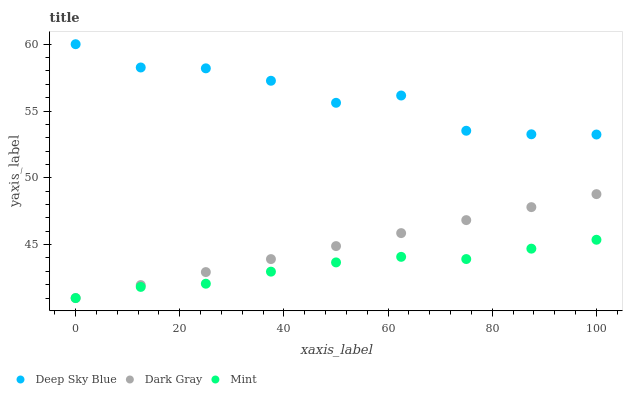Does Mint have the minimum area under the curve?
Answer yes or no. Yes. Does Deep Sky Blue have the maximum area under the curve?
Answer yes or no. Yes. Does Deep Sky Blue have the minimum area under the curve?
Answer yes or no. No. Does Mint have the maximum area under the curve?
Answer yes or no. No. Is Dark Gray the smoothest?
Answer yes or no. Yes. Is Deep Sky Blue the roughest?
Answer yes or no. Yes. Is Mint the smoothest?
Answer yes or no. No. Is Mint the roughest?
Answer yes or no. No. Does Dark Gray have the lowest value?
Answer yes or no. Yes. Does Deep Sky Blue have the lowest value?
Answer yes or no. No. Does Deep Sky Blue have the highest value?
Answer yes or no. Yes. Does Mint have the highest value?
Answer yes or no. No. Is Mint less than Deep Sky Blue?
Answer yes or no. Yes. Is Deep Sky Blue greater than Mint?
Answer yes or no. Yes. Does Dark Gray intersect Mint?
Answer yes or no. Yes. Is Dark Gray less than Mint?
Answer yes or no. No. Is Dark Gray greater than Mint?
Answer yes or no. No. Does Mint intersect Deep Sky Blue?
Answer yes or no. No. 